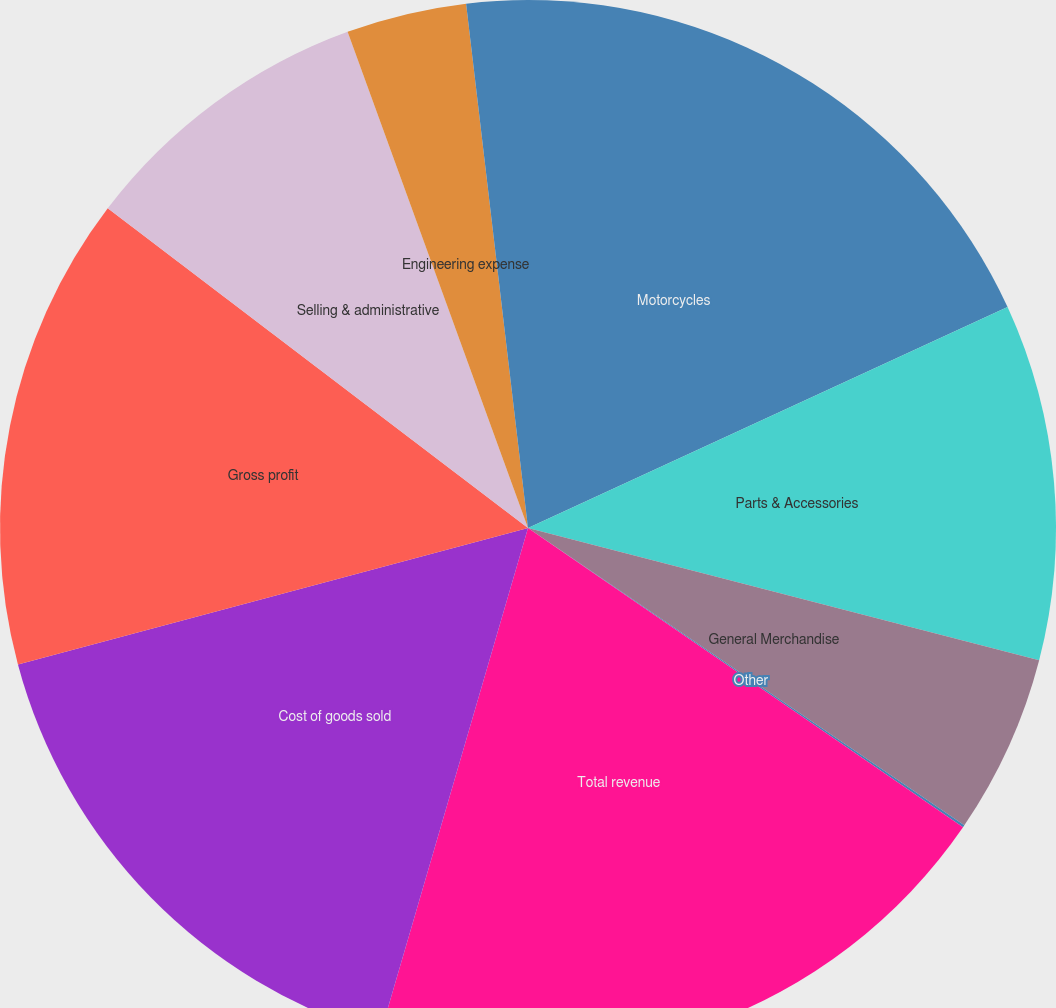Convert chart. <chart><loc_0><loc_0><loc_500><loc_500><pie_chart><fcel>Motorcycles<fcel>Parts & Accessories<fcel>General Merchandise<fcel>Other<fcel>Total revenue<fcel>Cost of goods sold<fcel>Gross profit<fcel>Selling & administrative<fcel>Engineering expense<fcel>Restructuring (benefit)<nl><fcel>18.13%<fcel>10.9%<fcel>5.49%<fcel>0.07%<fcel>19.93%<fcel>16.32%<fcel>14.51%<fcel>9.1%<fcel>3.68%<fcel>1.87%<nl></chart> 